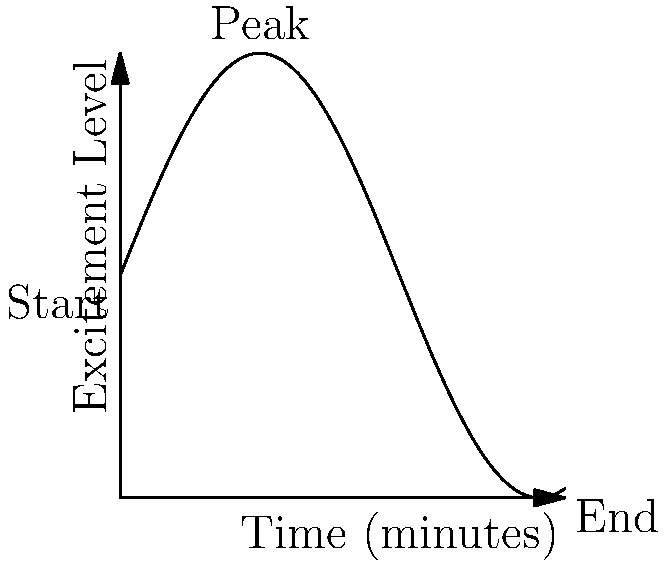During a 10-minute card performance, the audience's excitement level $E(t)$ can be modeled by the function $E(t) = 5\sin(t/2) + 5$, where $t$ is the time in minutes. Calculate the total accumulated excitement experienced by the audience throughout the entire performance. To find the total accumulated excitement, we need to calculate the area under the curve of $E(t)$ from $t=0$ to $t=10$. This can be done using a definite integral:

1) Set up the integral: 
   $$\int_0^{10} E(t) dt = \int_0^{10} (5\sin(t/2) + 5) dt$$

2) Split the integral:
   $$\int_0^{10} 5\sin(t/2) dt + \int_0^{10} 5 dt$$

3) Solve the first part:
   $$5 \int_0^{10} \sin(t/2) dt = -10\cos(t/2) \Big|_0^{10}$$
   $$= -10(\cos(5) - \cos(0)) = -10(\cos(5) - 1)$$

4) Solve the second part:
   $$5 \int_0^{10} dt = 5t \Big|_0^{10} = 50$$

5) Sum the results:
   $$-10(\cos(5) - 1) + 50 = -10\cos(5) + 10 + 50 = 60 - 10\cos(5)$$

Therefore, the total accumulated excitement is $60 - 10\cos(5)$ units.
Answer: $60 - 10\cos(5)$ units 